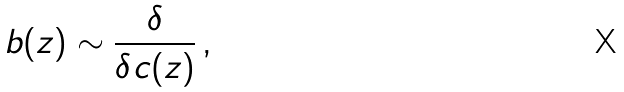<formula> <loc_0><loc_0><loc_500><loc_500>b ( z ) \sim \frac { \delta } { \delta c ( z ) } \, ,</formula> 